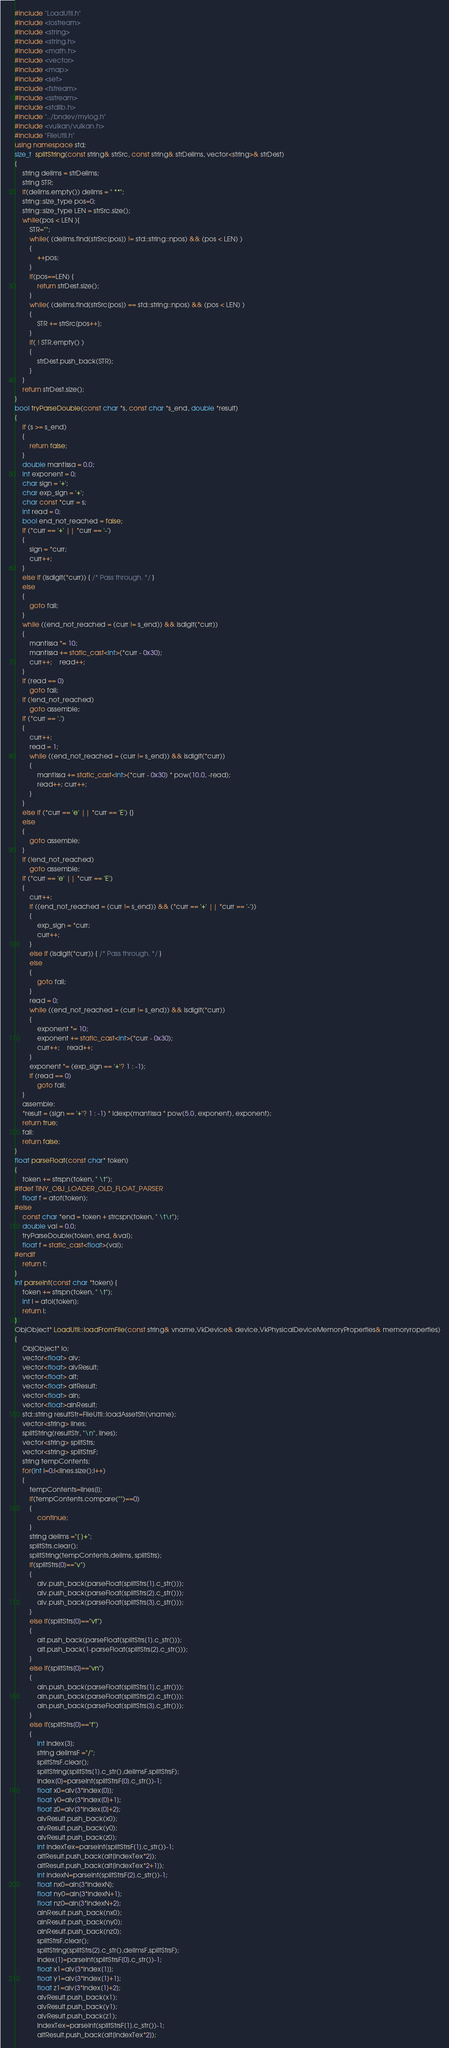<code> <loc_0><loc_0><loc_500><loc_500><_C++_>#include "LoadUtil.h"
#include <iostream>
#include <string>
#include <string.h>
#include <math.h>
#include <vector>
#include <map>
#include <set>
#include <fstream>
#include <sstream>
#include <stdlib.h>
#include "../bndev/mylog.h"
#include <vulkan/vulkan.h>
#include "FileUtil.h"
using namespace std;
size_t  splitString(const string& strSrc, const string& strDelims, vector<string>& strDest)
{
    string delims = strDelims;
    string STR;
    if(delims.empty()) delims = " **";
    string::size_type pos=0;
    string::size_type LEN = strSrc.size();
    while(pos < LEN ){
        STR="";
        while( (delims.find(strSrc[pos]) != std::string::npos) && (pos < LEN) )
        {
            ++pos;
        }
        if(pos==LEN) {
            return strDest.size();
        }
        while( (delims.find(strSrc[pos]) == std::string::npos) && (pos < LEN) )
        {
            STR += strSrc[pos++];
        }
        if( ! STR.empty() )
        {
            strDest.push_back(STR);
        }
    }
    return strDest.size();
}
bool tryParseDouble(const char *s, const char *s_end, double *result)
{
    if (s >= s_end)
    {
        return false;
    }
    double mantissa = 0.0;
    int exponent = 0;
    char sign = '+';
    char exp_sign = '+';
    char const *curr = s;
    int read = 0;
    bool end_not_reached = false;
    if (*curr == '+' || *curr == '-')
    {
        sign = *curr;
        curr++;
    }
    else if (isdigit(*curr)) { /* Pass through. */ }
    else
    {
        goto fail;
    }
    while ((end_not_reached = (curr != s_end)) && isdigit(*curr))
    {
        mantissa *= 10;
        mantissa += static_cast<int>(*curr - 0x30);
        curr++;	read++;
    }
    if (read == 0)
        goto fail;
    if (!end_not_reached)
        goto assemble;
    if (*curr == '.')
    {
        curr++;
        read = 1;
        while ((end_not_reached = (curr != s_end)) && isdigit(*curr))
        {
            mantissa += static_cast<int>(*curr - 0x30) * pow(10.0, -read);
            read++; curr++;
        }
    }
    else if (*curr == 'e' || *curr == 'E') {}
    else
    {
        goto assemble;
    }
    if (!end_not_reached)
        goto assemble;
    if (*curr == 'e' || *curr == 'E')
    {
        curr++;
        if ((end_not_reached = (curr != s_end)) && (*curr == '+' || *curr == '-'))
        {
            exp_sign = *curr;
            curr++;
        }
        else if (isdigit(*curr)) { /* Pass through. */ }
        else
        {
            goto fail;
        }
        read = 0;
        while ((end_not_reached = (curr != s_end)) && isdigit(*curr))
        {
            exponent *= 10;
            exponent += static_cast<int>(*curr - 0x30);
            curr++;	read++;
        }
        exponent *= (exp_sign == '+'? 1 : -1);
        if (read == 0)
            goto fail;
    }
    assemble:
    *result = (sign == '+'? 1 : -1) * ldexp(mantissa * pow(5.0, exponent), exponent);
    return true;
    fail:
    return false;
}
float parseFloat(const char* token)
{
    token += strspn(token, " \t");
#ifdef TINY_OBJ_LOADER_OLD_FLOAT_PARSER
    float f = atof(token);
#else
    const char *end = token + strcspn(token, " \t\r");
    double val = 0.0;
    tryParseDouble(token, end, &val);
    float f = static_cast<float>(val);
#endif
    return f;
}
int parseInt(const char *token) {
    token += strspn(token, " \t");
    int i = atoi(token);
    return i;
}
ObjObject* LoadUtil::loadFromFile(const string& vname,VkDevice& device,VkPhysicalDeviceMemoryProperties& memoryroperties)
{
    ObjObject* lo;
    vector<float> alv;
    vector<float> alvResult;
    vector<float> alt;
    vector<float> altResult;
    vector<float> aln;
    vector<float>alnResult;
    std::string resultStr=FileUtil::loadAssetStr(vname);
    vector<string> lines;
    splitString(resultStr, "\n", lines);
    vector<string> splitStrs;
    vector<string> splitStrsF;
    string tempContents;
    for(int i=0;i<lines.size();i++)
    {
        tempContents=lines[i];
        if(tempContents.compare("")==0)
        {
            continue;
        }
        string delims ="[ ]+";
        splitStrs.clear();
        splitString(tempContents,delims, splitStrs);
        if(splitStrs[0]=="v")
        {
            alv.push_back(parseFloat(splitStrs[1].c_str()));
            alv.push_back(parseFloat(splitStrs[2].c_str()));
            alv.push_back(parseFloat(splitStrs[3].c_str()));
        }
        else if(splitStrs[0]=="vt")
        {
            alt.push_back(parseFloat(splitStrs[1].c_str()));
            alt.push_back(1-parseFloat(splitStrs[2].c_str()));
        }
        else if(splitStrs[0]=="vn")
        {
            aln.push_back(parseFloat(splitStrs[1].c_str()));
            aln.push_back(parseFloat(splitStrs[2].c_str()));
            aln.push_back(parseFloat(splitStrs[3].c_str()));
        }
        else if(splitStrs[0]=="f")
        {
            int index[3];
            string delimsF ="/";
            splitStrsF.clear();
            splitString(splitStrs[1].c_str(),delimsF,splitStrsF);
            index[0]=parseInt(splitStrsF[0].c_str())-1;
            float x0=alv[3*index[0]];
            float y0=alv[3*index[0]+1];
            float z0=alv[3*index[0]+2];
            alvResult.push_back(x0);
            alvResult.push_back(y0);
            alvResult.push_back(z0);
            int indexTex=parseInt(splitStrsF[1].c_str())-1;
            altResult.push_back(alt[indexTex*2]);
            altResult.push_back(alt[indexTex*2+1]);
            int indexN=parseInt(splitStrsF[2].c_str())-1;
            float nx0=aln[3*indexN];
            float ny0=aln[3*indexN+1];
            float nz0=aln[3*indexN+2];
            alnResult.push_back(nx0);
            alnResult.push_back(ny0);
            alnResult.push_back(nz0);
            splitStrsF.clear();
            splitString(splitStrs[2].c_str(),delimsF,splitStrsF);
            index[1]=parseInt(splitStrsF[0].c_str())-1;
            float x1=alv[3*index[1]];
            float y1=alv[3*index[1]+1];
            float z1=alv[3*index[1]+2];
            alvResult.push_back(x1);
            alvResult.push_back(y1);
            alvResult.push_back(z1);
            indexTex=parseInt(splitStrsF[1].c_str())-1;
            altResult.push_back(alt[indexTex*2]);</code> 